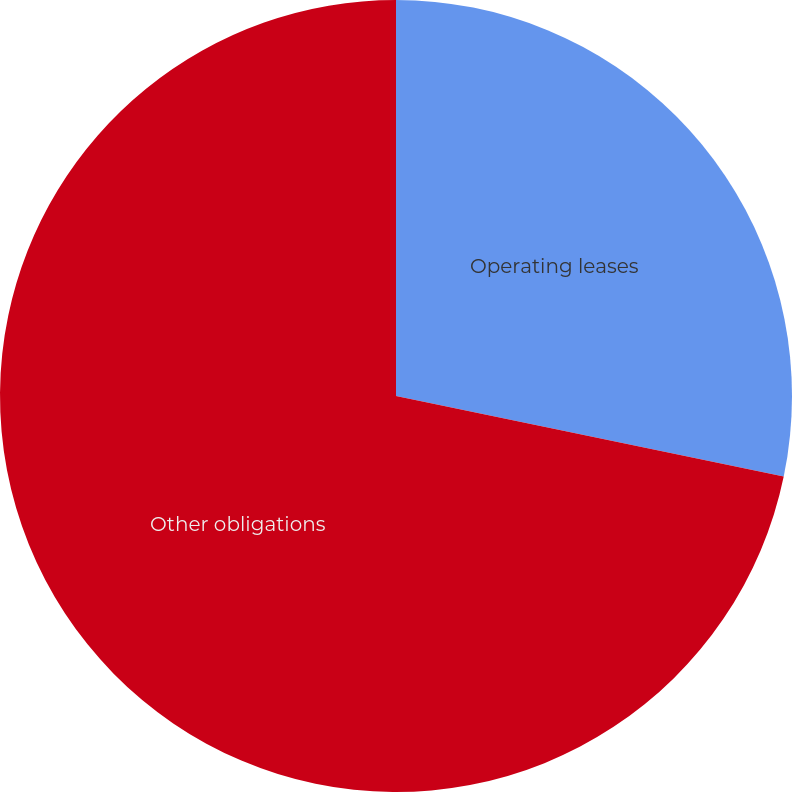<chart> <loc_0><loc_0><loc_500><loc_500><pie_chart><fcel>Operating leases<fcel>Other obligations<nl><fcel>28.26%<fcel>71.74%<nl></chart> 